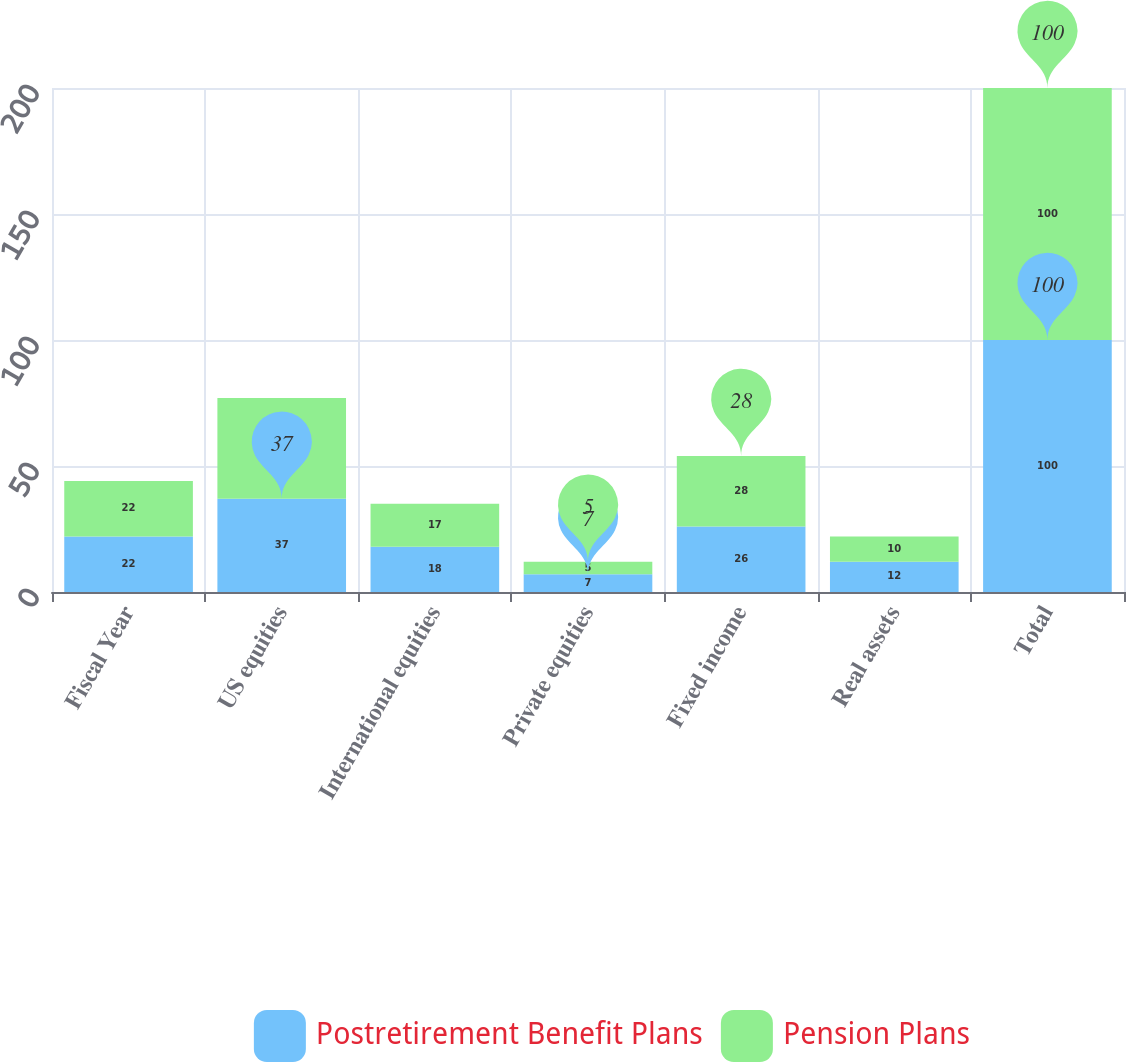Convert chart to OTSL. <chart><loc_0><loc_0><loc_500><loc_500><stacked_bar_chart><ecel><fcel>Fiscal Year<fcel>US equities<fcel>International equities<fcel>Private equities<fcel>Fixed income<fcel>Real assets<fcel>Total<nl><fcel>Postretirement Benefit Plans<fcel>22<fcel>37<fcel>18<fcel>7<fcel>26<fcel>12<fcel>100<nl><fcel>Pension Plans<fcel>22<fcel>40<fcel>17<fcel>5<fcel>28<fcel>10<fcel>100<nl></chart> 